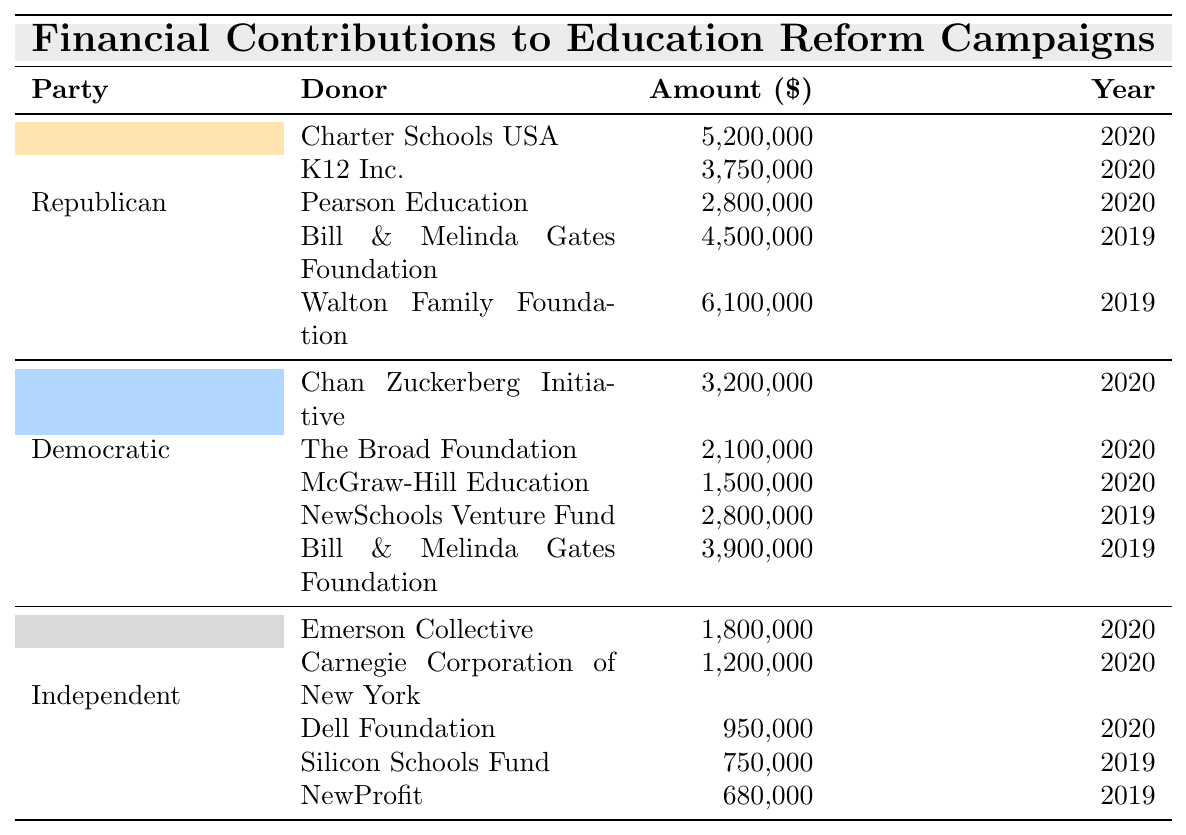What is the total amount contributed by the Republican Party in 2020? To find the total contributions from the Republican Party in 2020, we add the contributions from Charter Schools USA ($5,200,000), K12 Inc. ($3,750,000), and Pearson Education ($2,800,000). The sum is $5,200,000 + $3,750,000 + $2,800,000 = $11,750,000.
Answer: $11,750,000 Which donor contributed the most in the Democratic Party for the year 2019? From the Democratic Party's contributions for 2019, we examine the donors: NewSchools Venture Fund ($2,800,000) and Bill & Melinda Gates Foundation ($3,900,000). The highest contribution is from the Bill & Melinda Gates Foundation at $3,900,000.
Answer: Bill & Melinda Gates Foundation What was the total contribution from private sector entities to education reform campaigns by Independents in the year 2020? For Independents in 2020, the contributions are from Emerson Collective ($1,800,000), Carnegie Corporation of New York ($1,200,000), and Dell Foundation ($950,000). Adding them gives $1,800,000 + $1,200,000 + $950,000 = $3,950,000.
Answer: $3,950,000 Which party received the highest total contributions in 2019, and what was the total amount? In 2019, the totals for each party are as follows: Republican Party: $4,500,000 (Bill & Melinda Gates Foundation) + $6,100,000 (Walton Family Foundation) = $10,600,000. Democratic Party: $3,900,000 (Bill & Melinda Gates Foundation) + $2,800,000 (NewSchools Venture Fund) = $6,700,000. Independents: $750,000 (Silicon Schools Fund) + $680,000 (NewProfit) = $1,430,000. The Republican Party had the highest contributions with a total of $10,600,000.
Answer: Republican Party, $10,600,000 How many total donors contributed the sum of contributions for the Democratic Party in 2020? Examining the Democratic Party's donors in 2020, we see Chan Zuckerberg Initiative, The Broad Foundation, and McGraw-Hill Education. There are a total of 3 donors.
Answer: 3 Is the contribution amount from the Walton Family Foundation higher than any contribution from the Democratic Party donors in 2019? The contribution from the Walton Family Foundation was $6,100,000 in 2019. The Democratic Party's contributions in 2019 are $2,800,000 (NewSchools Venture Fund) and $3,900,000 (Bill & Melinda Gates Foundation). Both are less than $6,100,000, so the statement is true.
Answer: Yes Which party had the least amount of total contributions across both years? Adding contributions from all parties: Republican Party total = $11,750,000 (2020) + $10,600,000 (2019) = $22,350,000; Democratic Party total = $6,700,000 (2019) + $6,800,000 (2020) = $13,500,000; Independent total = $3,950,000 (2020) + $1,430,000 (2019) = $5,380,000. The Independent Party had the least with $5,380,000.
Answer: Independent Party, $5,380,000 What is the average contribution amount from Republican donors listed in the table? The total contributions from Republican donors are $5,200,000 + $3,750,000 + $2,800,000 + $4,500,000 + $6,100,000 = $22,350,000. There are 5 donors, so the average is $22,350,000 / 5 = $4,470,000.
Answer: $4,470,000 What is the total contribution amount from the Chan Zuckerberg Initiative and The Broad Foundation combined? The contributions were $3,200,000 from Chan Zuckerberg Initiative and $2,100,000 from The Broad Foundation. Summing these amounts gives $3,200,000 + $2,100,000 = $5,300,000.
Answer: $5,300,000 Verify if the total donations from Democratic Party donors in both years equals the contributions from all Independent donors. The total for Democrats is $6,700,000 (2019) + $6,300,000 (2020) = $13,000,000. For Independents: $1,430,000 (2019) + $3,950,000 (2020) = $5,380,000. Since $13,000,000 does not equal $5,380,000, this statement is false.
Answer: No 